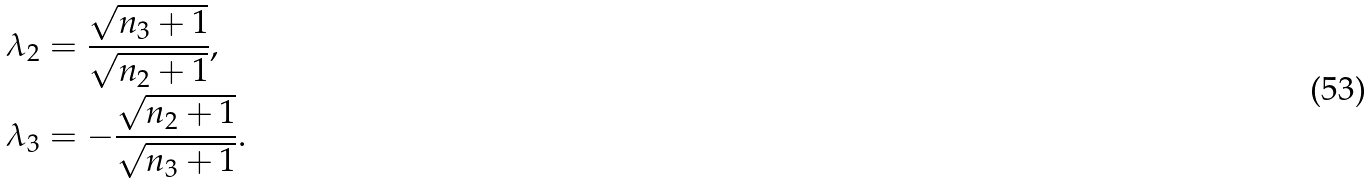Convert formula to latex. <formula><loc_0><loc_0><loc_500><loc_500>& \lambda _ { 2 } = \frac { \sqrt { n _ { 3 } + 1 } } { \sqrt { n _ { 2 } + 1 } } , \\ & \lambda _ { 3 } = - \frac { \sqrt { n _ { 2 } + 1 } } { \sqrt { n _ { 3 } + 1 } } .</formula> 